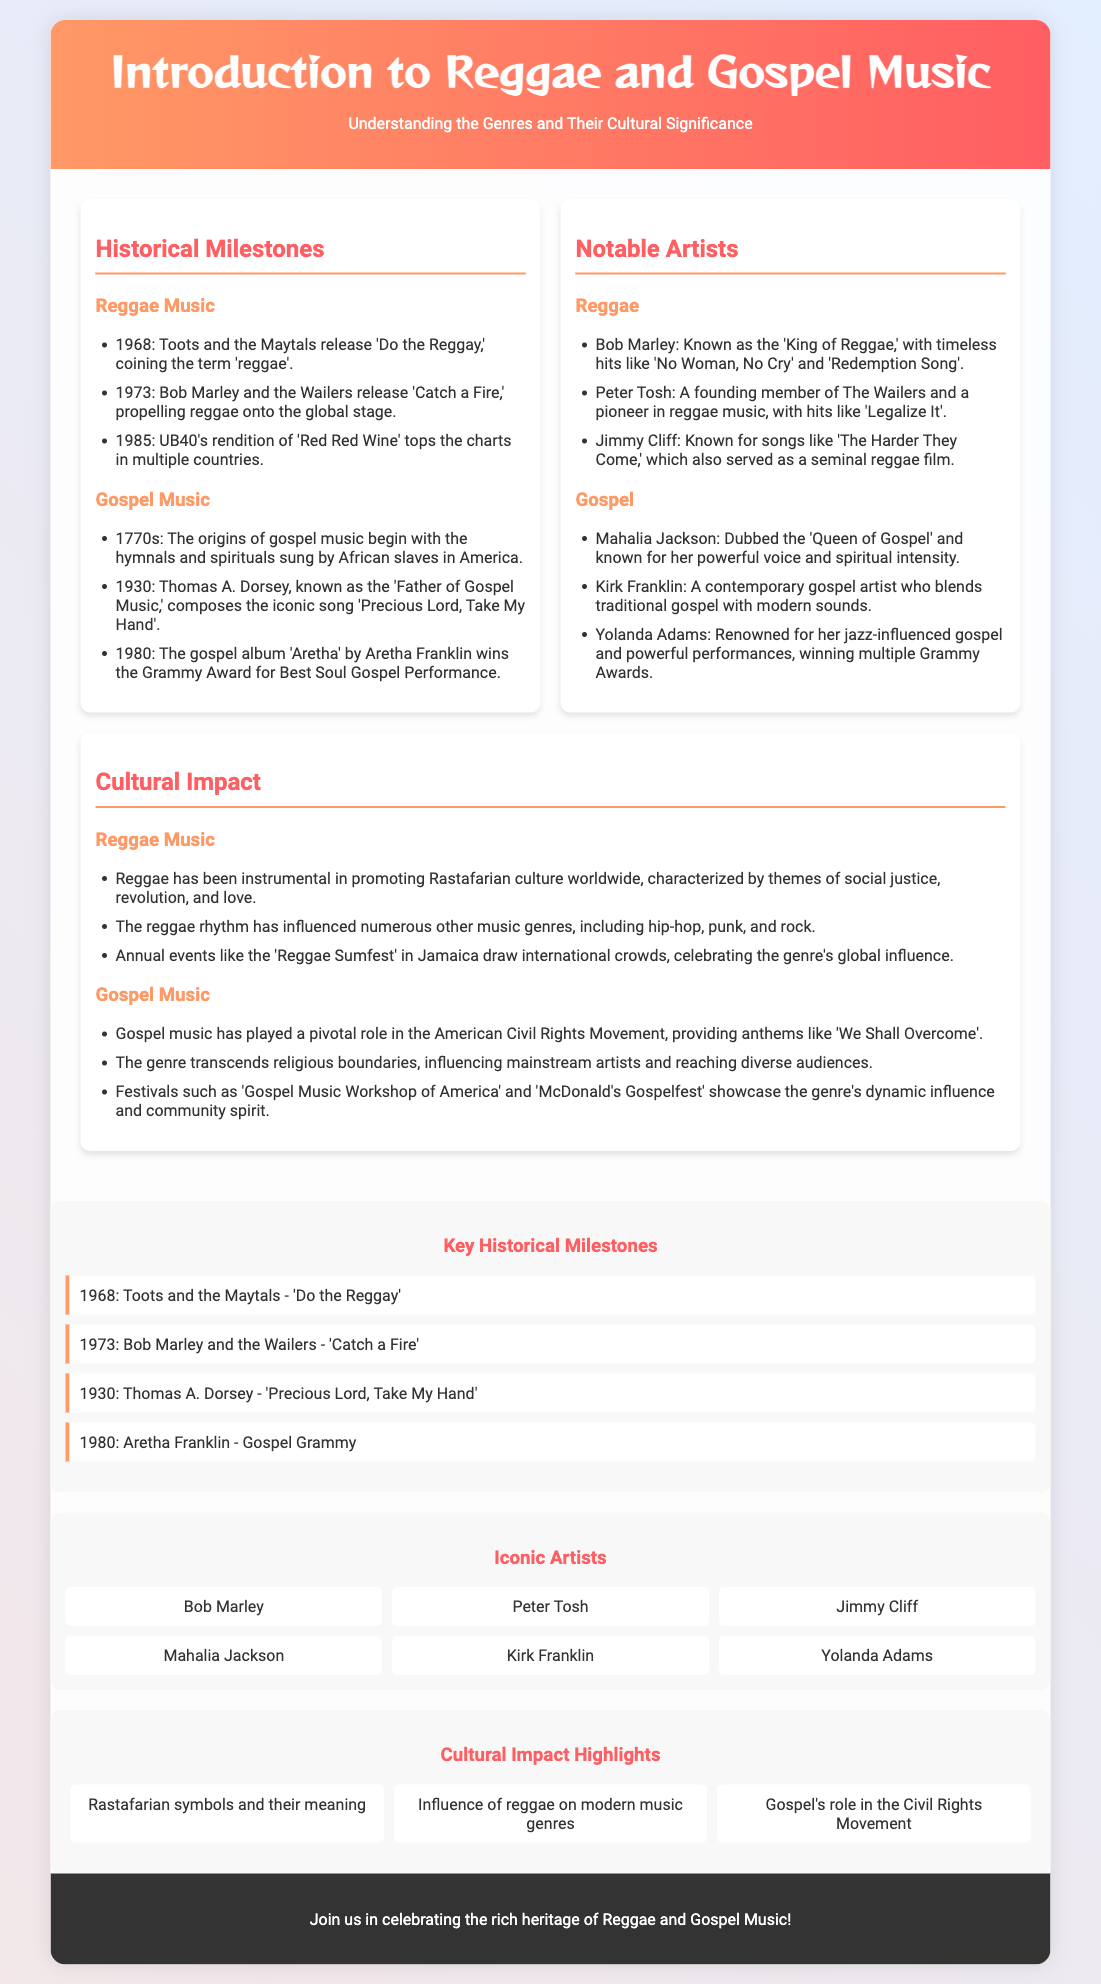what significant milestone did Toots and the Maytals achieve in 1968? Toots and the Maytals released 'Do the Reggay,' coining the term 'reggae'.
Answer: 'Do the Reggay' who is known as the 'Father of Gospel Music'? Thomas A. Dorsey is referred to as the 'Father of Gospel Music'.
Answer: Thomas A. Dorsey which gospel artist won a Grammy Award for Best Soul Gospel Performance in 1980? Aretha Franklin's gospel album 'Aretha' won the Grammy Award for Best Soul Gospel Performance in 1980.
Answer: Aretha Franklin what theme is prominently associated with reggae music? Reggae promotes Rastafarian culture and themes of social justice, revolution, and love.
Answer: social justice which notable reggae artist is known for the song 'Legalize It'? Peter Tosh is known for the song 'Legalize It'.
Answer: Peter Tosh how did gospel music influence the American Civil Rights Movement? Gospel music provided anthems like 'We Shall Overcome' during the Civil Rights Movement.
Answer: anthems what type of music did Kirk Franklin blend with traditional gospel? Kirk Franklin blends contemporary sounds with traditional gospel music.
Answer: contemporary sounds how many notable reggae artists are listed in the flyer? The flyer lists three notable reggae artists.
Answer: three what cultural event is mentioned as a celebration of reggae's global influence? The 'Reggae Sumfest' in Jamaica is mentioned as a celebration of reggae's global influence.
Answer: Reggae Sumfest 